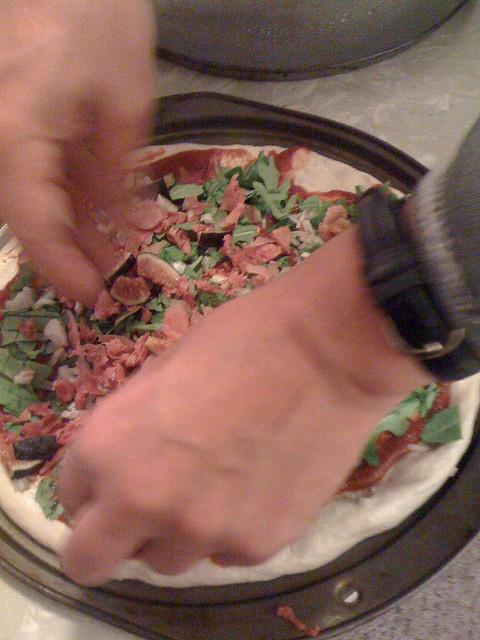What is on the person wrist?
Answer briefly. Watch. Is there meat on it?
Be succinct. Yes. What is being made?
Quick response, please. Pizza. 